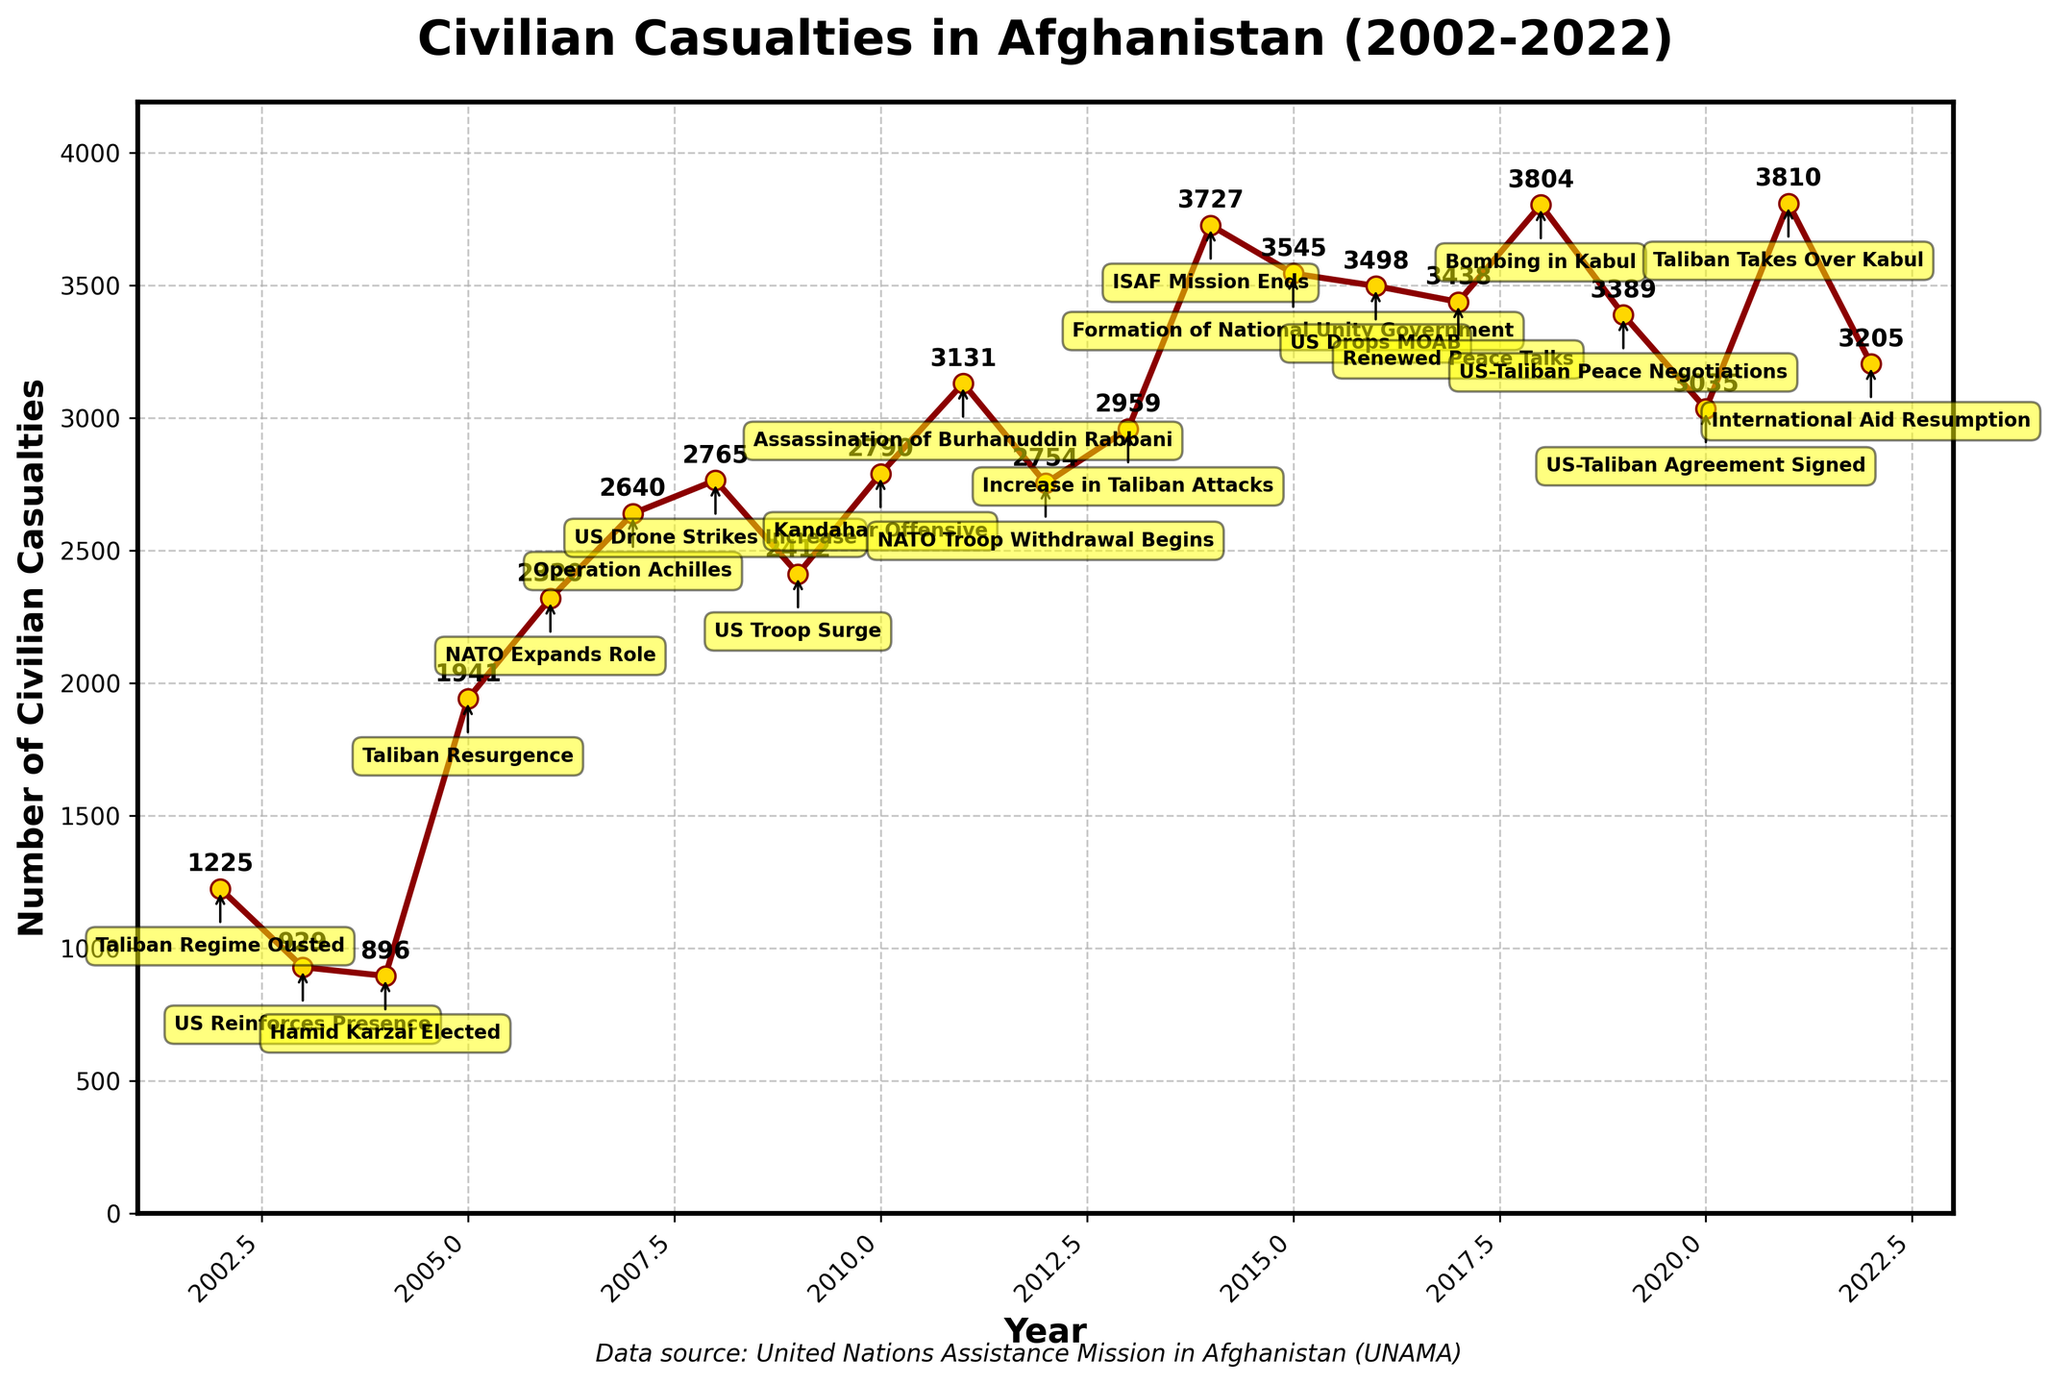What is the title of the plot? The title is usually located at the top of the plot and is written in bold text. The title of the plot summarizes the overall content being shown. Here, it provides context about the data.
Answer: Civilian Casualties in Afghanistan (2002-2022) How many data points are plotted on the time series? The number of data points corresponds to the number of years listed on the x-axis. Each year from 2002 to 2022 represents one data point. To find the number of data points, count the years listed on the x-axis.
Answer: 21 What is the trend in civilian casualties from 2002 to 2005? To determine the trend, observe the direction of the line from 2002 to 2005. The number of casualties decreases initially and then starts to increase. Examine the plot from 2002 to 2005 where the line first dips and then ascends.
Answer: Decrease then increase Which year had the highest number of civilian casualties? To identify the highest number, examine the peaks of the plot line. The highest point on the y-axis that corresponds to a year will be the year with the highest casualties. Look for the highest peak on the plot.
Answer: 2014 In which year did the Taliban take over Kabul, and what was the civilian casualty count in that year? Look for the label that indicates the Taliban taking over Kabul. This is identified near the peak in 2021, where it's annotated with a text box. Read both the event annotation and the corresponding y-axis value.
Answer: 2021, 3810 What is the overall trend of civilian casualties from 2019 to 2022? Observe the plot line from 2019 to 2022 to see if it generally increases or decreases. The plot line’s slope will indicate trends. Note if it's generally declining, which indicates a decrease.
Answer: Decrease Between which two consecutive years did the civilian casualties show the greatest decrease? Determine the difference between each pair of consecutive years by looking at the slope. The steepest downward slope indicates the greatest decrease. Compare each descending step.
Answer: 2018 to 2019 How do the civilian casualty counts compare between 2005 and 2007? To compare values, find the points for 2005 and 2007 on the x-axis, and read their corresponding y-axis values. Compare the two numbers to see which is larger.
Answer: 2007 is higher What event is mentioned in 2009, and how did it affect the trend in civilian casualties? The event annotation indicated near 2009 is notable; observe the trend change surrounding this year. Identify the direction of the line around it to understand its impact. The line decreases just after this event.
Answer: US Troop Surge, decrease What is the median number of civilian casualties from 2002 to 2022? To find the median, sort the casualty numbers from 2002 to 2022 in ascending order and identify the middle value. Since there are 21 data points, the median will be the 11th value in this ordered list.
Answer: 2765 